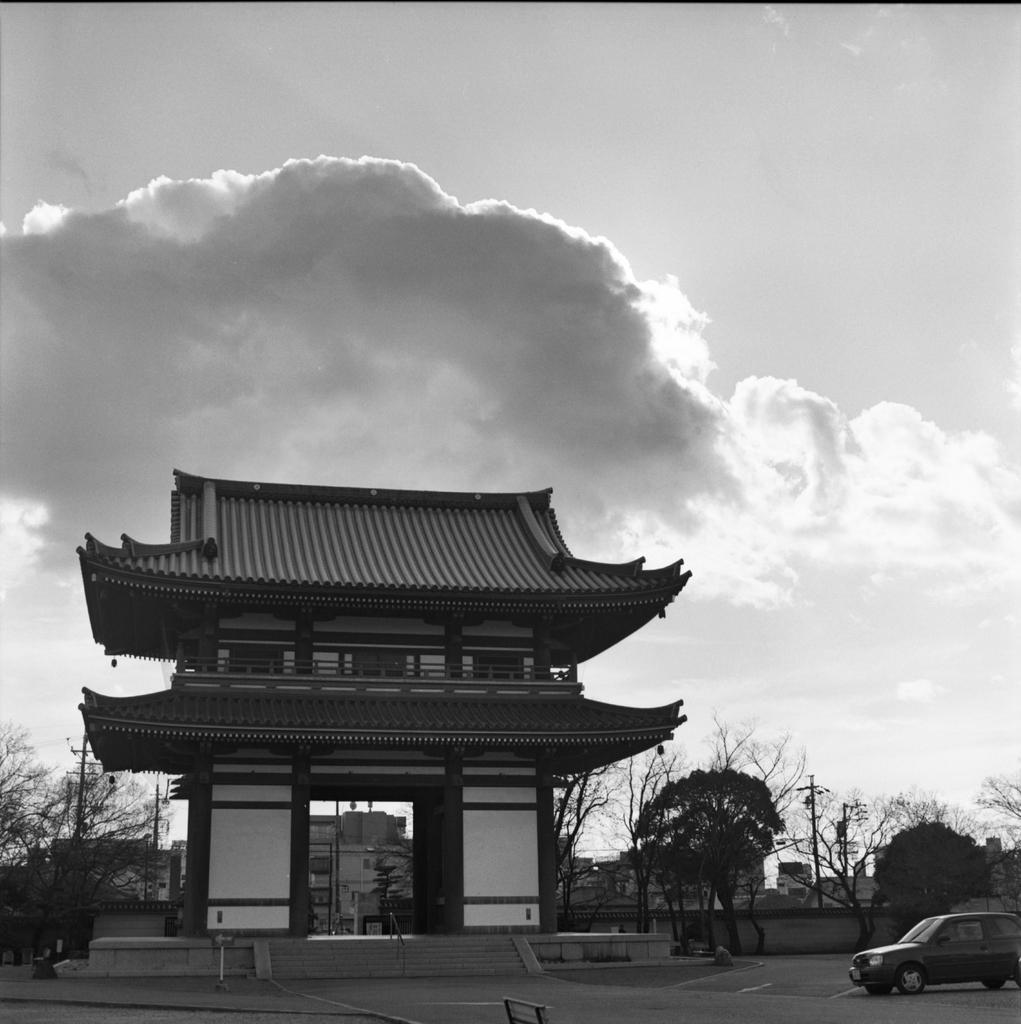Could you give a brief overview of what you see in this image? In the center of the image there is an arch. On the right side of the image we can see car, road, wall, pole and trees. In the background there is a sky and clouds. 